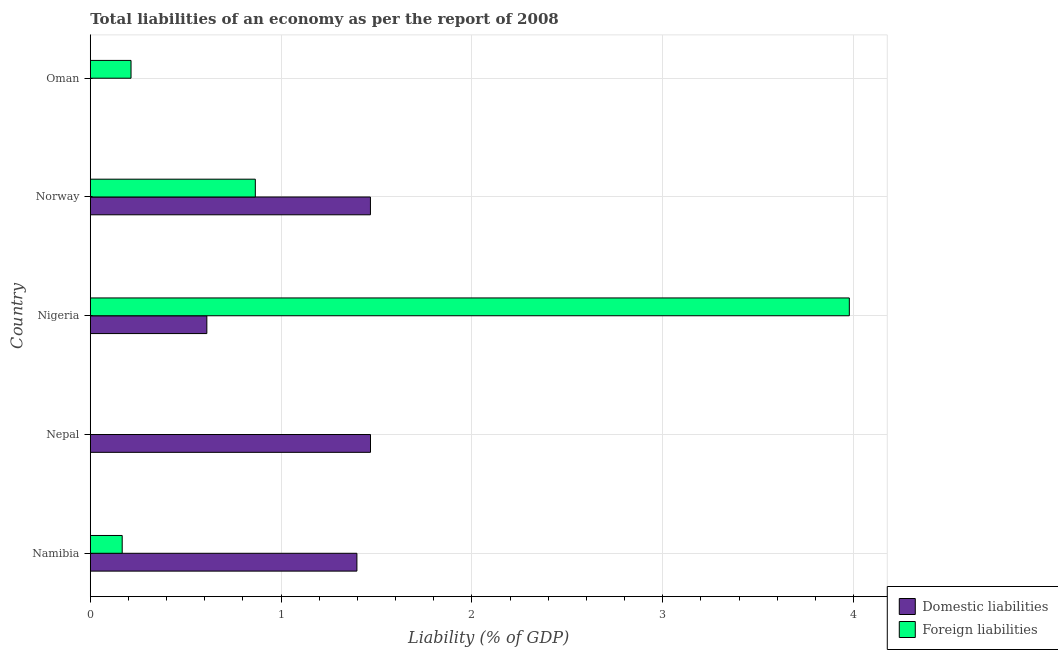How many different coloured bars are there?
Your answer should be compact. 2. How many bars are there on the 5th tick from the top?
Provide a succinct answer. 2. How many bars are there on the 2nd tick from the bottom?
Offer a terse response. 1. What is the label of the 1st group of bars from the top?
Offer a very short reply. Oman. Across all countries, what is the maximum incurrence of domestic liabilities?
Provide a succinct answer. 1.47. In which country was the incurrence of foreign liabilities maximum?
Give a very brief answer. Nigeria. What is the total incurrence of domestic liabilities in the graph?
Give a very brief answer. 4.95. What is the difference between the incurrence of foreign liabilities in Namibia and that in Norway?
Provide a short and direct response. -0.7. What is the difference between the incurrence of domestic liabilities in Nigeria and the incurrence of foreign liabilities in Namibia?
Keep it short and to the point. 0.44. What is the difference between the incurrence of foreign liabilities and incurrence of domestic liabilities in Nigeria?
Give a very brief answer. 3.37. What is the ratio of the incurrence of foreign liabilities in Norway to that in Oman?
Ensure brevity in your answer.  4.05. What is the difference between the highest and the second highest incurrence of domestic liabilities?
Provide a short and direct response. 0. What is the difference between the highest and the lowest incurrence of domestic liabilities?
Provide a short and direct response. 1.47. How many bars are there?
Make the answer very short. 8. Are the values on the major ticks of X-axis written in scientific E-notation?
Your answer should be compact. No. Does the graph contain grids?
Provide a succinct answer. Yes. What is the title of the graph?
Provide a short and direct response. Total liabilities of an economy as per the report of 2008. What is the label or title of the X-axis?
Provide a short and direct response. Liability (% of GDP). What is the Liability (% of GDP) in Domestic liabilities in Namibia?
Your response must be concise. 1.4. What is the Liability (% of GDP) of Foreign liabilities in Namibia?
Provide a short and direct response. 0.17. What is the Liability (% of GDP) in Domestic liabilities in Nepal?
Your answer should be compact. 1.47. What is the Liability (% of GDP) of Domestic liabilities in Nigeria?
Your answer should be very brief. 0.61. What is the Liability (% of GDP) in Foreign liabilities in Nigeria?
Offer a terse response. 3.98. What is the Liability (% of GDP) of Domestic liabilities in Norway?
Your answer should be very brief. 1.47. What is the Liability (% of GDP) of Foreign liabilities in Norway?
Make the answer very short. 0.87. What is the Liability (% of GDP) in Domestic liabilities in Oman?
Keep it short and to the point. 0. What is the Liability (% of GDP) of Foreign liabilities in Oman?
Make the answer very short. 0.21. Across all countries, what is the maximum Liability (% of GDP) of Domestic liabilities?
Your answer should be compact. 1.47. Across all countries, what is the maximum Liability (% of GDP) in Foreign liabilities?
Your answer should be very brief. 3.98. Across all countries, what is the minimum Liability (% of GDP) of Domestic liabilities?
Provide a succinct answer. 0. What is the total Liability (% of GDP) in Domestic liabilities in the graph?
Make the answer very short. 4.95. What is the total Liability (% of GDP) in Foreign liabilities in the graph?
Your answer should be compact. 5.22. What is the difference between the Liability (% of GDP) in Domestic liabilities in Namibia and that in Nepal?
Your answer should be very brief. -0.07. What is the difference between the Liability (% of GDP) of Domestic liabilities in Namibia and that in Nigeria?
Offer a terse response. 0.79. What is the difference between the Liability (% of GDP) of Foreign liabilities in Namibia and that in Nigeria?
Ensure brevity in your answer.  -3.81. What is the difference between the Liability (% of GDP) of Domestic liabilities in Namibia and that in Norway?
Ensure brevity in your answer.  -0.07. What is the difference between the Liability (% of GDP) in Foreign liabilities in Namibia and that in Norway?
Make the answer very short. -0.7. What is the difference between the Liability (% of GDP) in Foreign liabilities in Namibia and that in Oman?
Your answer should be very brief. -0.05. What is the difference between the Liability (% of GDP) of Domestic liabilities in Nepal and that in Nigeria?
Provide a succinct answer. 0.86. What is the difference between the Liability (% of GDP) of Domestic liabilities in Nepal and that in Norway?
Your answer should be very brief. 0. What is the difference between the Liability (% of GDP) of Domestic liabilities in Nigeria and that in Norway?
Offer a terse response. -0.86. What is the difference between the Liability (% of GDP) in Foreign liabilities in Nigeria and that in Norway?
Make the answer very short. 3.11. What is the difference between the Liability (% of GDP) of Foreign liabilities in Nigeria and that in Oman?
Provide a short and direct response. 3.76. What is the difference between the Liability (% of GDP) of Foreign liabilities in Norway and that in Oman?
Your answer should be very brief. 0.65. What is the difference between the Liability (% of GDP) of Domestic liabilities in Namibia and the Liability (% of GDP) of Foreign liabilities in Nigeria?
Give a very brief answer. -2.58. What is the difference between the Liability (% of GDP) of Domestic liabilities in Namibia and the Liability (% of GDP) of Foreign liabilities in Norway?
Your answer should be very brief. 0.53. What is the difference between the Liability (% of GDP) in Domestic liabilities in Namibia and the Liability (% of GDP) in Foreign liabilities in Oman?
Your answer should be compact. 1.18. What is the difference between the Liability (% of GDP) in Domestic liabilities in Nepal and the Liability (% of GDP) in Foreign liabilities in Nigeria?
Offer a terse response. -2.51. What is the difference between the Liability (% of GDP) of Domestic liabilities in Nepal and the Liability (% of GDP) of Foreign liabilities in Norway?
Offer a terse response. 0.6. What is the difference between the Liability (% of GDP) of Domestic liabilities in Nepal and the Liability (% of GDP) of Foreign liabilities in Oman?
Ensure brevity in your answer.  1.25. What is the difference between the Liability (% of GDP) of Domestic liabilities in Nigeria and the Liability (% of GDP) of Foreign liabilities in Norway?
Make the answer very short. -0.25. What is the difference between the Liability (% of GDP) of Domestic liabilities in Nigeria and the Liability (% of GDP) of Foreign liabilities in Oman?
Your answer should be very brief. 0.4. What is the difference between the Liability (% of GDP) of Domestic liabilities in Norway and the Liability (% of GDP) of Foreign liabilities in Oman?
Your answer should be very brief. 1.25. What is the average Liability (% of GDP) of Domestic liabilities per country?
Provide a succinct answer. 0.99. What is the average Liability (% of GDP) in Foreign liabilities per country?
Give a very brief answer. 1.04. What is the difference between the Liability (% of GDP) of Domestic liabilities and Liability (% of GDP) of Foreign liabilities in Namibia?
Offer a terse response. 1.23. What is the difference between the Liability (% of GDP) of Domestic liabilities and Liability (% of GDP) of Foreign liabilities in Nigeria?
Offer a terse response. -3.37. What is the difference between the Liability (% of GDP) in Domestic liabilities and Liability (% of GDP) in Foreign liabilities in Norway?
Your answer should be compact. 0.6. What is the ratio of the Liability (% of GDP) in Domestic liabilities in Namibia to that in Nepal?
Keep it short and to the point. 0.95. What is the ratio of the Liability (% of GDP) of Domestic liabilities in Namibia to that in Nigeria?
Keep it short and to the point. 2.29. What is the ratio of the Liability (% of GDP) in Foreign liabilities in Namibia to that in Nigeria?
Ensure brevity in your answer.  0.04. What is the ratio of the Liability (% of GDP) of Domestic liabilities in Namibia to that in Norway?
Your answer should be very brief. 0.95. What is the ratio of the Liability (% of GDP) of Foreign liabilities in Namibia to that in Norway?
Offer a terse response. 0.19. What is the ratio of the Liability (% of GDP) of Foreign liabilities in Namibia to that in Oman?
Ensure brevity in your answer.  0.78. What is the ratio of the Liability (% of GDP) of Domestic liabilities in Nepal to that in Nigeria?
Offer a very short reply. 2.4. What is the ratio of the Liability (% of GDP) of Domestic liabilities in Nepal to that in Norway?
Make the answer very short. 1. What is the ratio of the Liability (% of GDP) of Domestic liabilities in Nigeria to that in Norway?
Provide a short and direct response. 0.42. What is the ratio of the Liability (% of GDP) in Foreign liabilities in Nigeria to that in Norway?
Offer a terse response. 4.6. What is the ratio of the Liability (% of GDP) of Foreign liabilities in Nigeria to that in Oman?
Offer a terse response. 18.62. What is the ratio of the Liability (% of GDP) of Foreign liabilities in Norway to that in Oman?
Your response must be concise. 4.05. What is the difference between the highest and the second highest Liability (% of GDP) of Foreign liabilities?
Your answer should be very brief. 3.11. What is the difference between the highest and the lowest Liability (% of GDP) of Domestic liabilities?
Offer a very short reply. 1.47. What is the difference between the highest and the lowest Liability (% of GDP) in Foreign liabilities?
Ensure brevity in your answer.  3.98. 